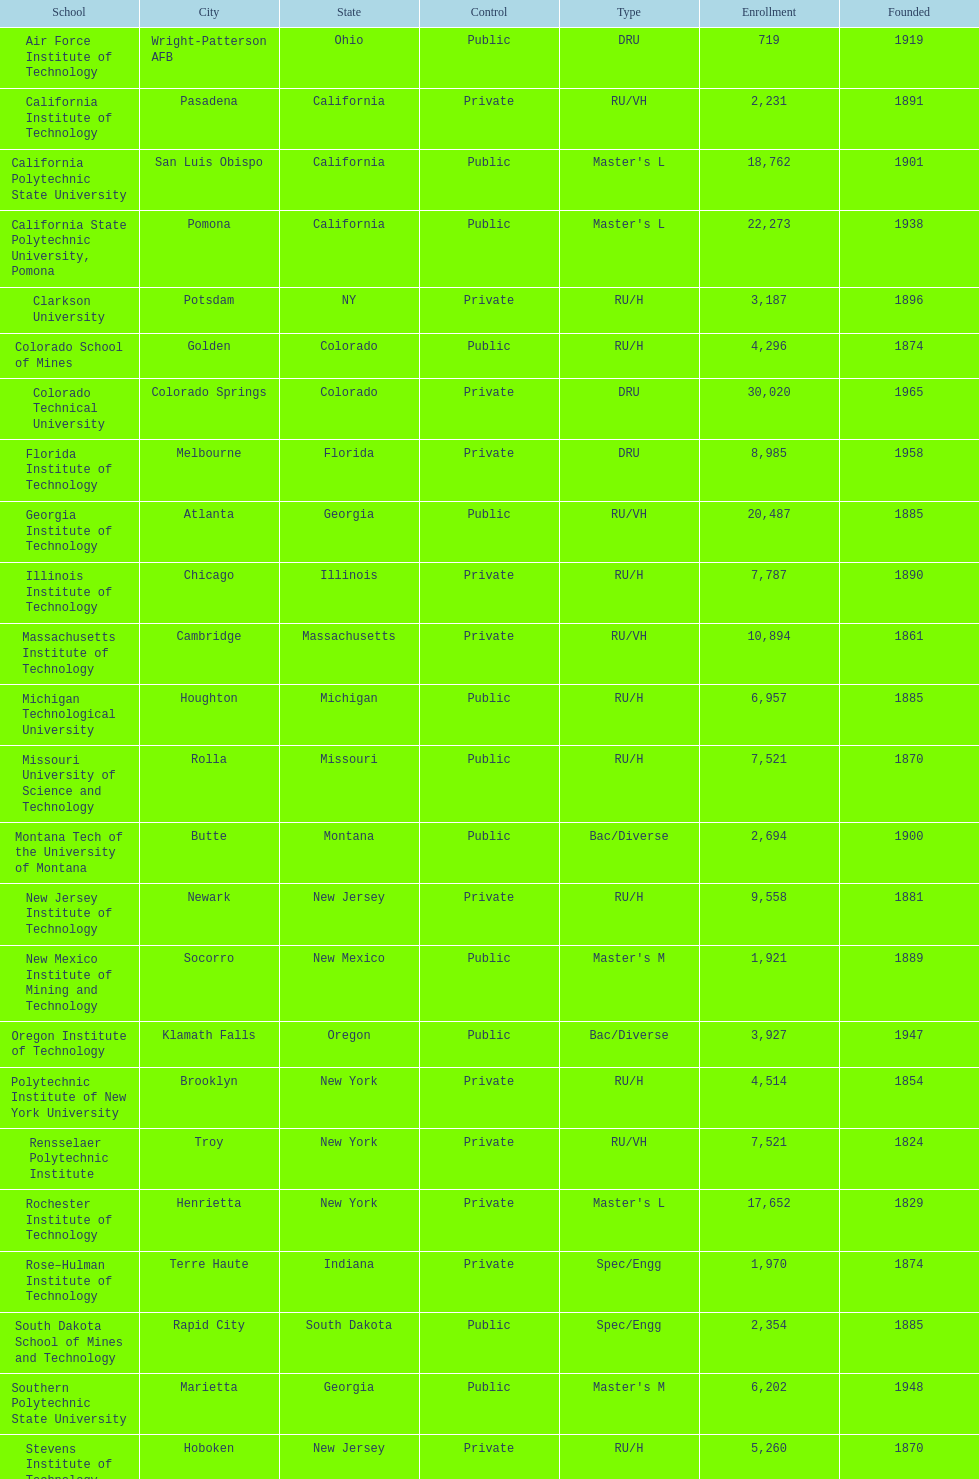What is the total number of schools listed in the table? 28. 